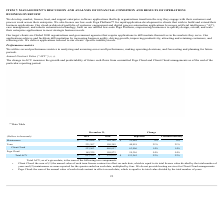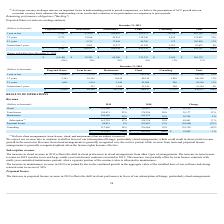From Pegasystems's financial document, What are the respective values for maintenance in 2018 and 2019? The document shows two values: $269,708 and $292,696 (in thousands). From the document: "Maintenance $ 292,696 $ 269,708 $ 22,988 9% 8% Maintenance $ 292,696 $ 269,708 $ 22,988 9% 8%..." Also, What are the respective values for Term in 2018 and 2019? The document shows two values: 190,349 and 231,267 (in thousands). From the document: "Term 231,267 190,349 40,918 21% 21% Term 231,267 190,349 40,918 21% 21%..." Also, What are the respective values for total ACV in 2018 and 2019? The document shows two values: $570,030 and $693,292 (in thousands). From the document: "Total ACV $ 693,292 $ 570,030 $ 123,262 22% 22% Total ACV $ 693,292 $ 570,030 $ 123,262 22% 22%..." Also, can you calculate: What is the percentage change in the maintenance values between 2018 and 2019? To answer this question, I need to perform calculations using the financial data. The calculation is: (292,696 - 269,708)/269,708 , which equals 8.52 (percentage). This is based on the information: "Maintenance $ 292,696 $ 269,708 $ 22,988 9% 8% Maintenance $ 292,696 $ 269,708 $ 22,988 9% 8%..." The key data points involved are: 269,708, 292,696. Also, can you calculate: What is the value of Client Cloud as a percentage of the total ACV in 2019? Based on the calculation: 523,963/693,292 , the result is 75.58 (percentage). This is based on the information: "Total ACV $ 693,292 $ 570,030 $ 123,262 22% 22% Client Cloud 523,963 460,057 63,906 14% 14%..." The key data points involved are: 523,963, 693,292. Also, can you calculate: What is the value of Pega Cloud as a percentage of the total ACV in 2019? Based on the calculation: 169,329/693,292 , the result is 24.42 (percentage). This is based on the information: "Total ACV $ 693,292 $ 570,030 $ 123,262 22% 22% Pega Cloud 169,329 109,973 59,356 54% 54%..." The key data points involved are: 169,329, 693,292. 